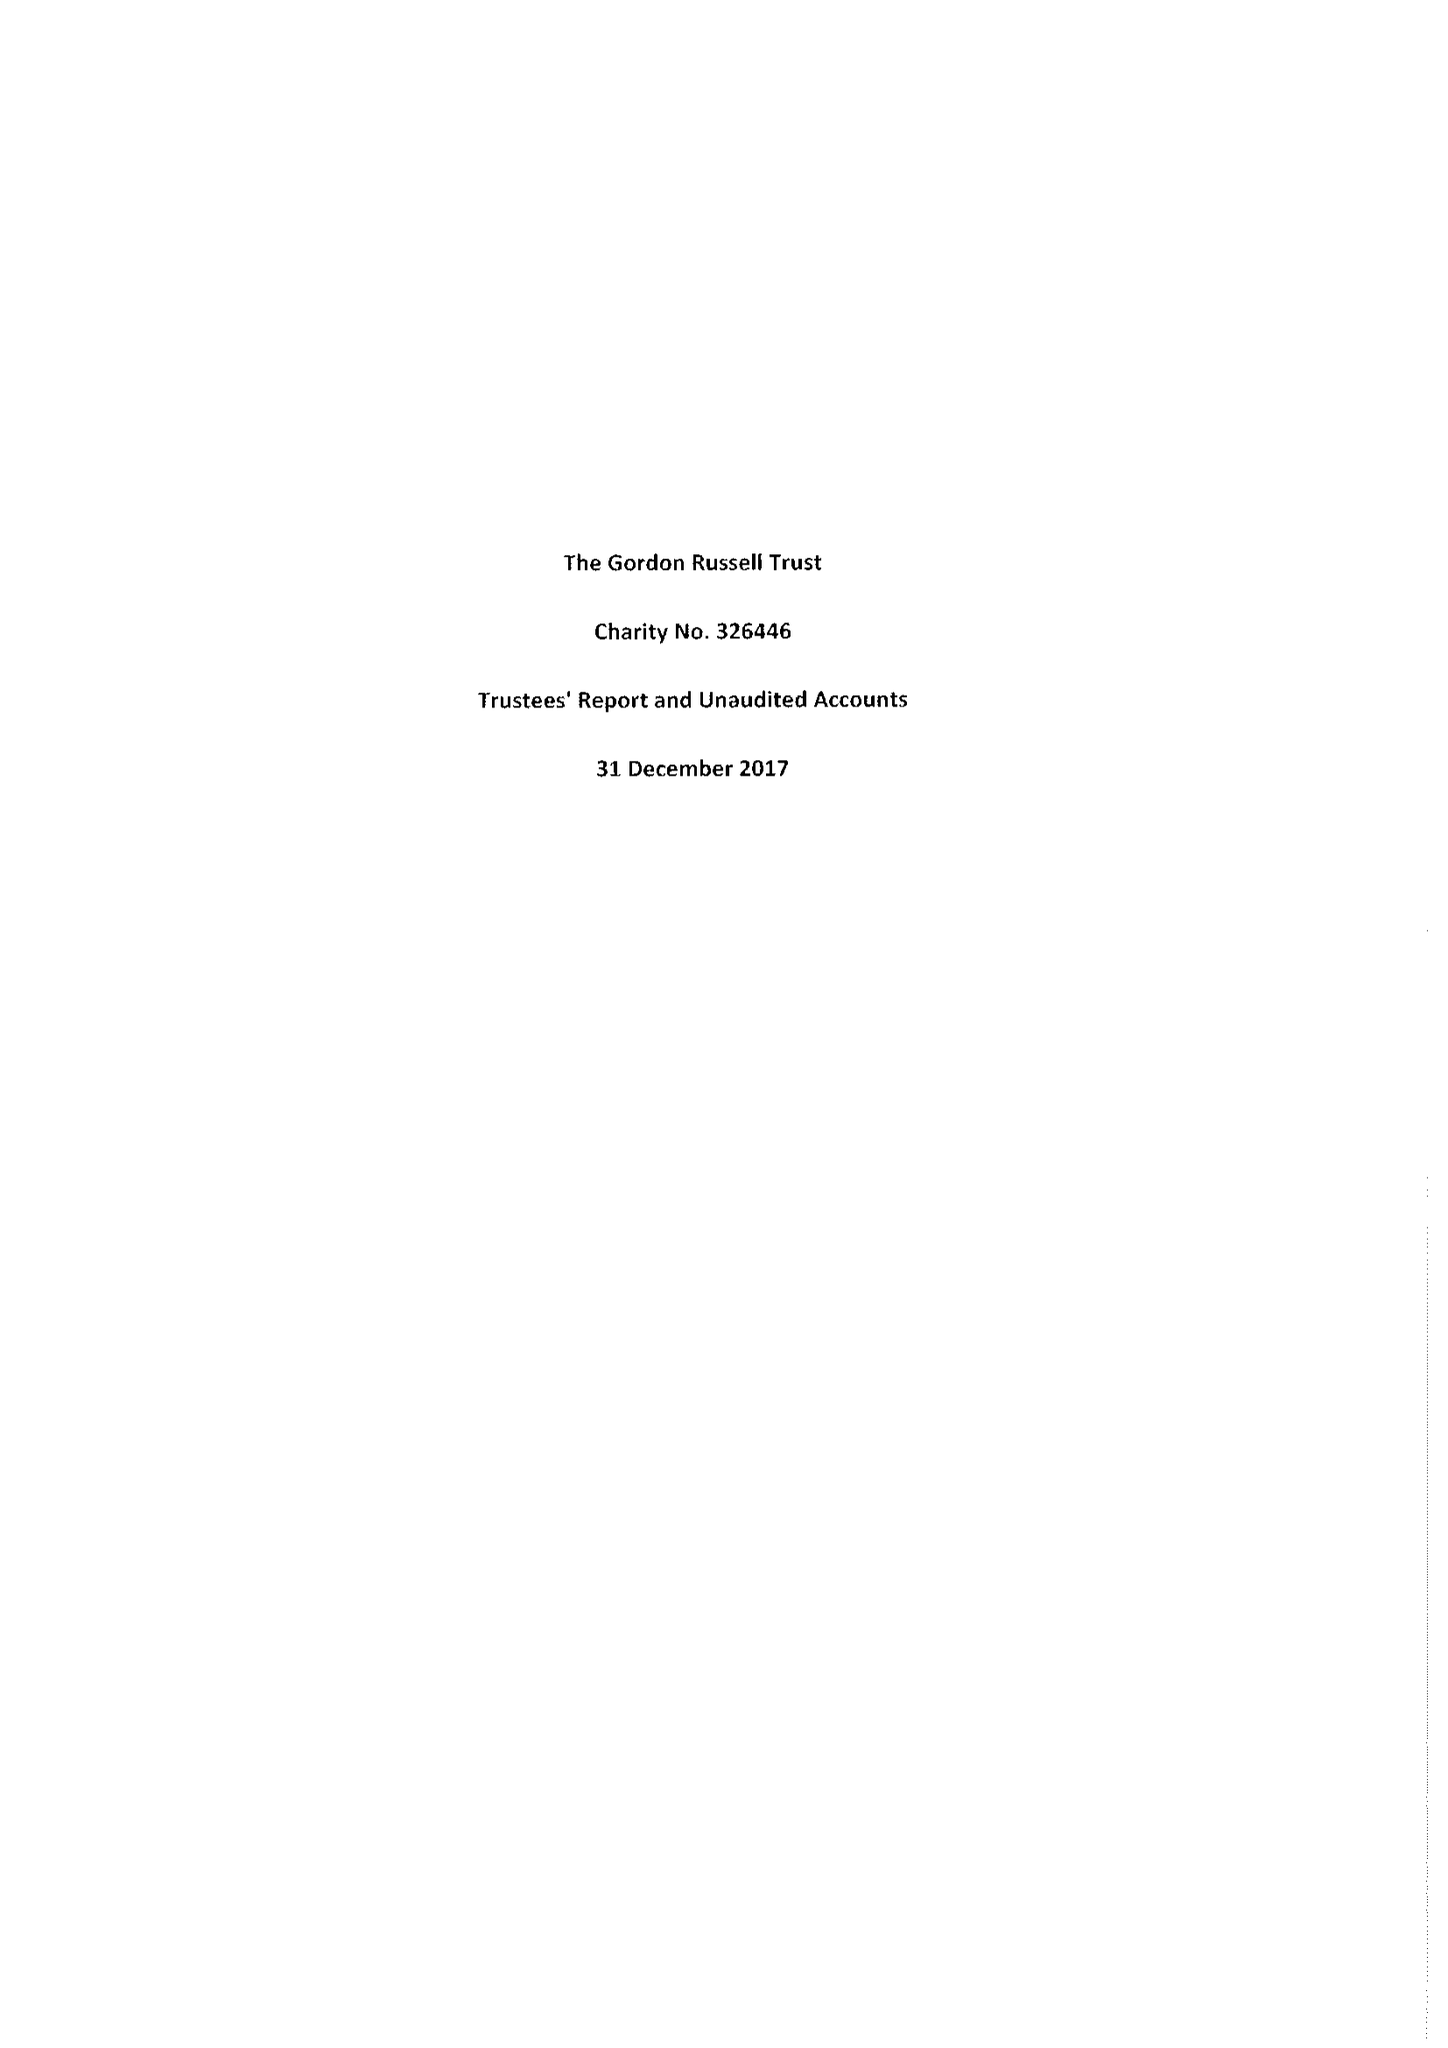What is the value for the address__postcode?
Answer the question using a single word or phrase. WR12 7AP 